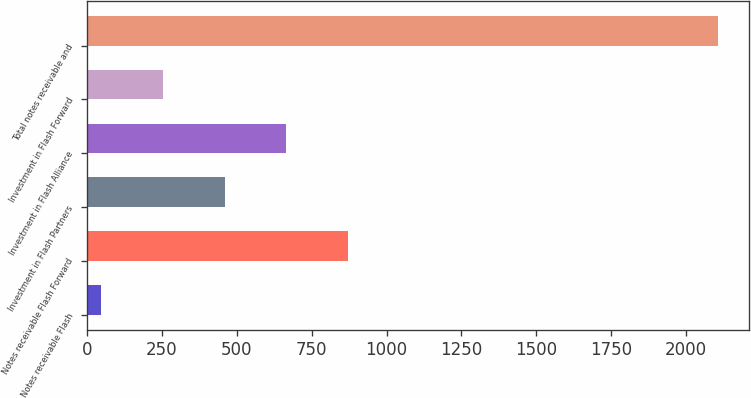<chart> <loc_0><loc_0><loc_500><loc_500><bar_chart><fcel>Notes receivable Flash<fcel>Notes receivable Flash Forward<fcel>Investment in Flash Partners<fcel>Investment in Flash Alliance<fcel>Investment in Flash Forward<fcel>Total notes receivable and<nl><fcel>48<fcel>870.8<fcel>459.4<fcel>665.1<fcel>253.7<fcel>2105<nl></chart> 